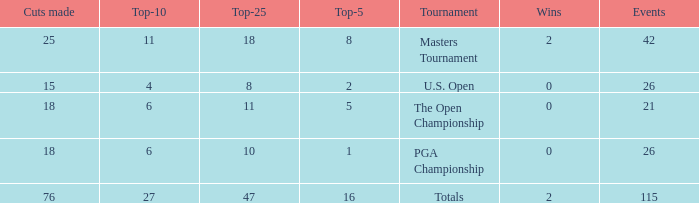How many average cuts made when 11 is the Top-10? 25.0. 